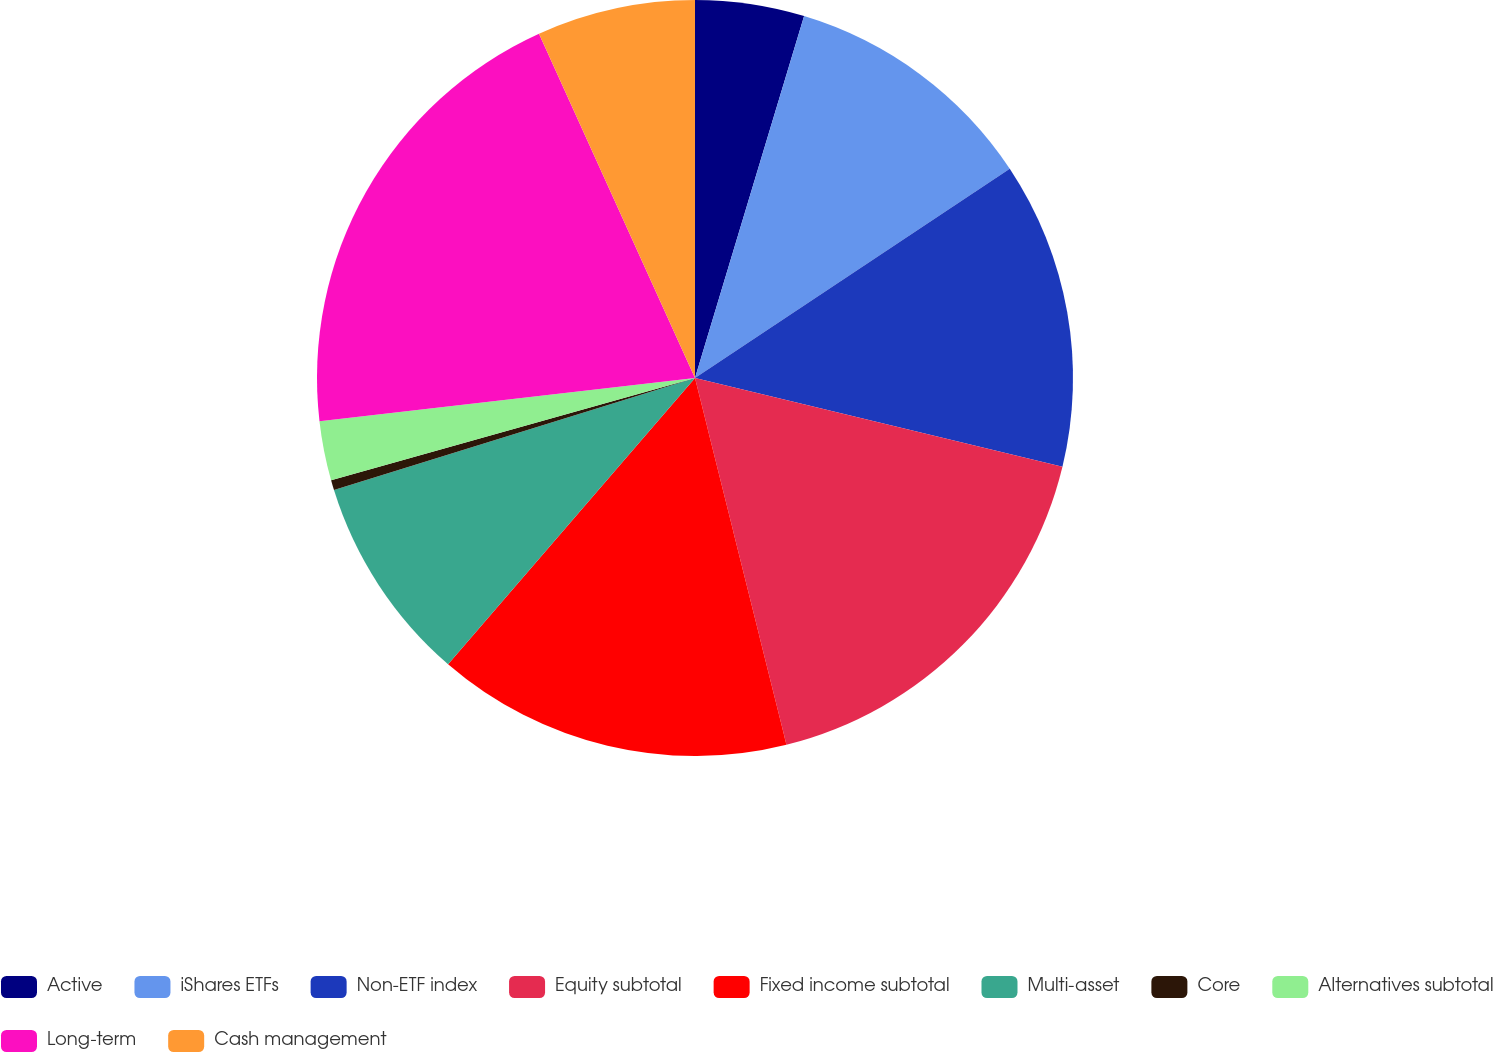<chart> <loc_0><loc_0><loc_500><loc_500><pie_chart><fcel>Active<fcel>iShares ETFs<fcel>Non-ETF index<fcel>Equity subtotal<fcel>Fixed income subtotal<fcel>Multi-asset<fcel>Core<fcel>Alternatives subtotal<fcel>Long-term<fcel>Cash management<nl><fcel>4.66%<fcel>11.0%<fcel>13.11%<fcel>17.34%<fcel>15.22%<fcel>8.88%<fcel>0.43%<fcel>2.54%<fcel>20.05%<fcel>6.77%<nl></chart> 